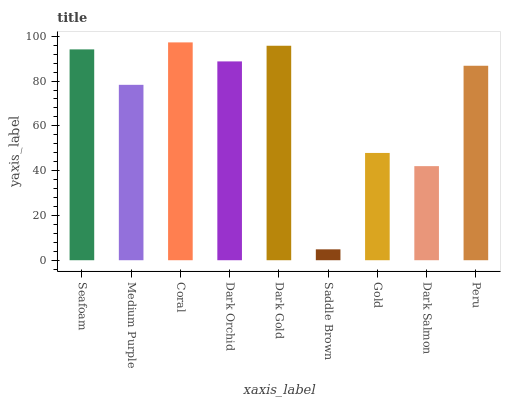Is Saddle Brown the minimum?
Answer yes or no. Yes. Is Coral the maximum?
Answer yes or no. Yes. Is Medium Purple the minimum?
Answer yes or no. No. Is Medium Purple the maximum?
Answer yes or no. No. Is Seafoam greater than Medium Purple?
Answer yes or no. Yes. Is Medium Purple less than Seafoam?
Answer yes or no. Yes. Is Medium Purple greater than Seafoam?
Answer yes or no. No. Is Seafoam less than Medium Purple?
Answer yes or no. No. Is Peru the high median?
Answer yes or no. Yes. Is Peru the low median?
Answer yes or no. Yes. Is Gold the high median?
Answer yes or no. No. Is Gold the low median?
Answer yes or no. No. 